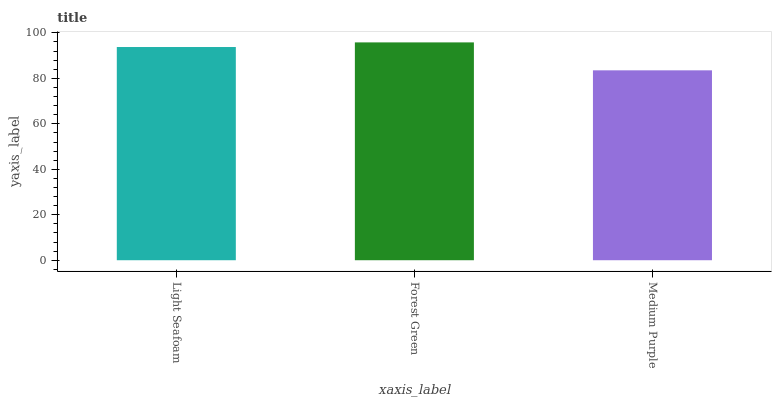Is Medium Purple the minimum?
Answer yes or no. Yes. Is Forest Green the maximum?
Answer yes or no. Yes. Is Forest Green the minimum?
Answer yes or no. No. Is Medium Purple the maximum?
Answer yes or no. No. Is Forest Green greater than Medium Purple?
Answer yes or no. Yes. Is Medium Purple less than Forest Green?
Answer yes or no. Yes. Is Medium Purple greater than Forest Green?
Answer yes or no. No. Is Forest Green less than Medium Purple?
Answer yes or no. No. Is Light Seafoam the high median?
Answer yes or no. Yes. Is Light Seafoam the low median?
Answer yes or no. Yes. Is Medium Purple the high median?
Answer yes or no. No. Is Medium Purple the low median?
Answer yes or no. No. 